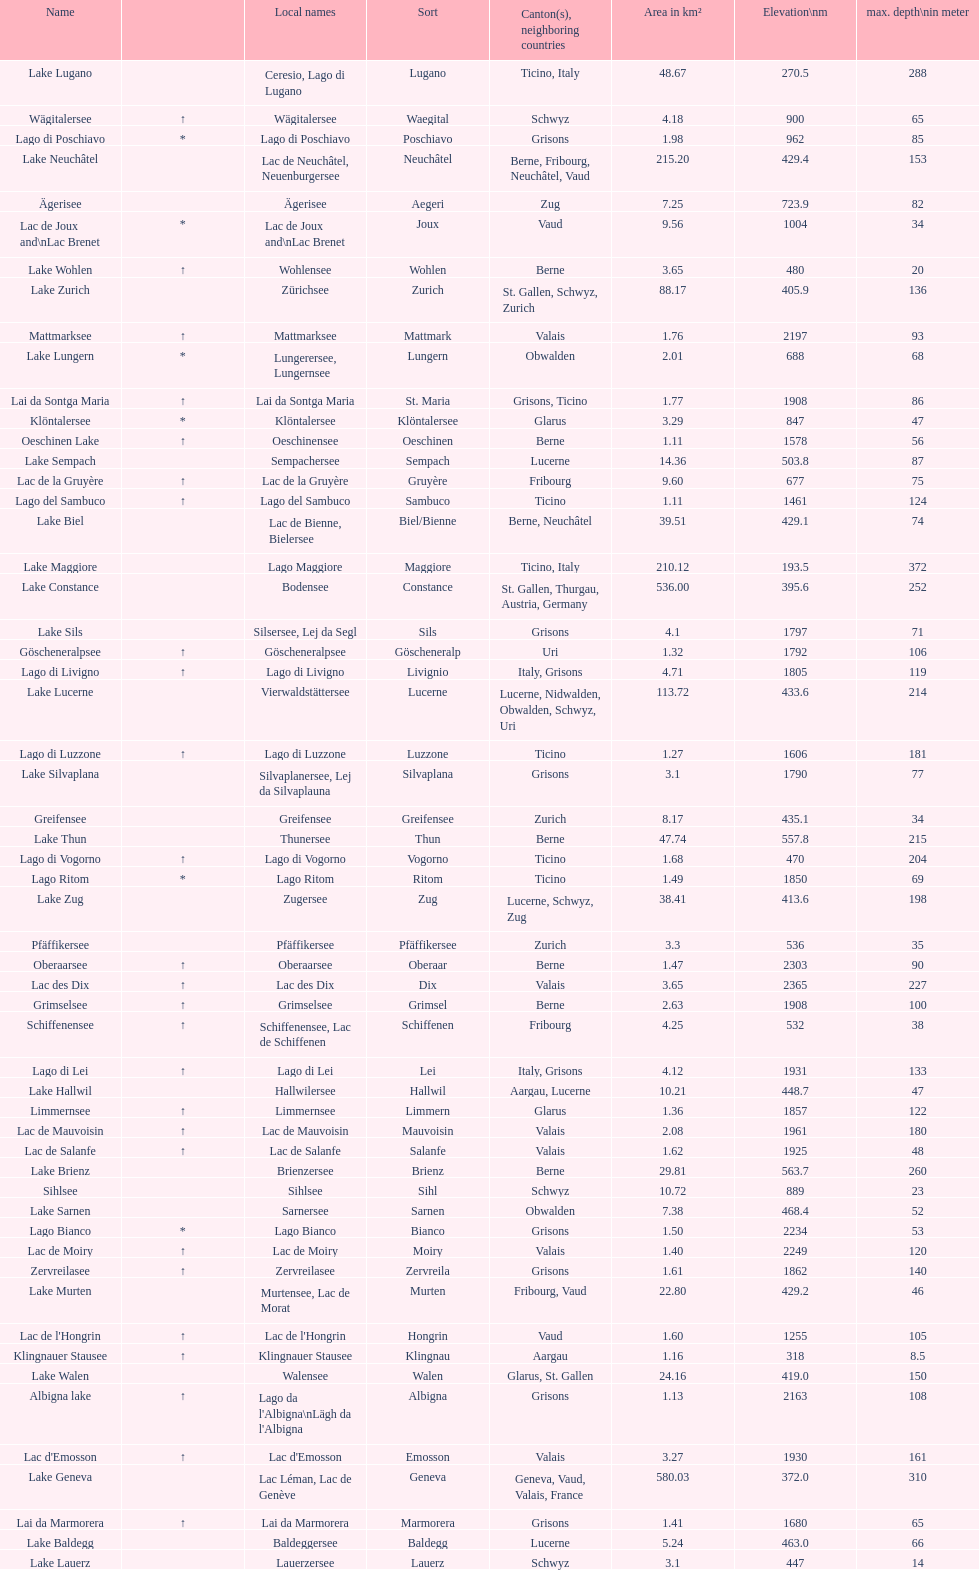Which lake is located at an elevation above 193m? Lake Maggiore. 